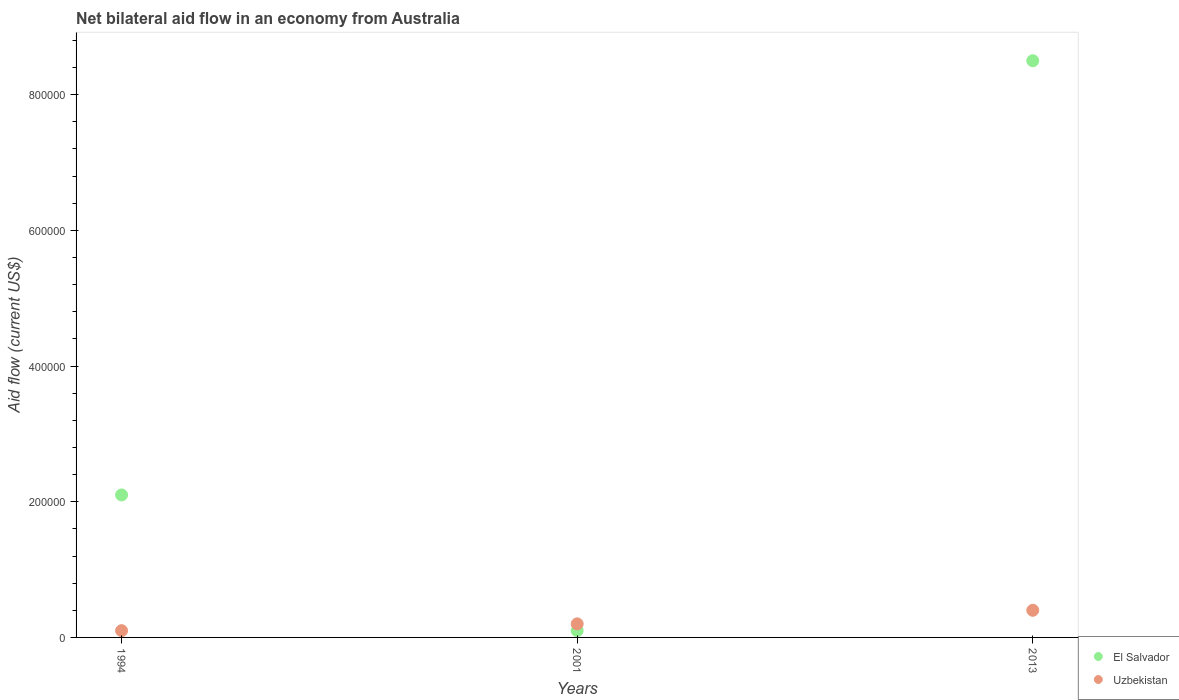How many different coloured dotlines are there?
Make the answer very short. 2. What is the net bilateral aid flow in El Salvador in 1994?
Ensure brevity in your answer.  2.10e+05. Across all years, what is the minimum net bilateral aid flow in Uzbekistan?
Provide a succinct answer. 10000. In which year was the net bilateral aid flow in El Salvador minimum?
Your answer should be very brief. 2001. What is the total net bilateral aid flow in Uzbekistan in the graph?
Ensure brevity in your answer.  7.00e+04. What is the difference between the net bilateral aid flow in Uzbekistan in 1994 and the net bilateral aid flow in El Salvador in 2013?
Provide a succinct answer. -8.40e+05. What is the average net bilateral aid flow in El Salvador per year?
Offer a very short reply. 3.57e+05. In the year 2013, what is the difference between the net bilateral aid flow in Uzbekistan and net bilateral aid flow in El Salvador?
Make the answer very short. -8.10e+05. In how many years, is the net bilateral aid flow in El Salvador greater than 280000 US$?
Your answer should be very brief. 1. What is the ratio of the net bilateral aid flow in El Salvador in 1994 to that in 2013?
Your response must be concise. 0.25. Is the difference between the net bilateral aid flow in Uzbekistan in 1994 and 2013 greater than the difference between the net bilateral aid flow in El Salvador in 1994 and 2013?
Offer a very short reply. Yes. What is the difference between the highest and the second highest net bilateral aid flow in El Salvador?
Offer a terse response. 6.40e+05. Does the net bilateral aid flow in Uzbekistan monotonically increase over the years?
Your answer should be compact. Yes. Is the net bilateral aid flow in Uzbekistan strictly less than the net bilateral aid flow in El Salvador over the years?
Give a very brief answer. No. How many dotlines are there?
Make the answer very short. 2. How many years are there in the graph?
Provide a succinct answer. 3. What is the difference between two consecutive major ticks on the Y-axis?
Your answer should be very brief. 2.00e+05. Does the graph contain any zero values?
Offer a terse response. No. How many legend labels are there?
Your answer should be compact. 2. How are the legend labels stacked?
Ensure brevity in your answer.  Vertical. What is the title of the graph?
Your answer should be very brief. Net bilateral aid flow in an economy from Australia. What is the label or title of the Y-axis?
Offer a very short reply. Aid flow (current US$). What is the Aid flow (current US$) in Uzbekistan in 1994?
Provide a short and direct response. 10000. What is the Aid flow (current US$) of El Salvador in 2001?
Give a very brief answer. 10000. What is the Aid flow (current US$) in El Salvador in 2013?
Provide a short and direct response. 8.50e+05. Across all years, what is the maximum Aid flow (current US$) in El Salvador?
Keep it short and to the point. 8.50e+05. What is the total Aid flow (current US$) of El Salvador in the graph?
Give a very brief answer. 1.07e+06. What is the total Aid flow (current US$) in Uzbekistan in the graph?
Offer a very short reply. 7.00e+04. What is the difference between the Aid flow (current US$) in El Salvador in 1994 and that in 2001?
Offer a terse response. 2.00e+05. What is the difference between the Aid flow (current US$) of El Salvador in 1994 and that in 2013?
Provide a succinct answer. -6.40e+05. What is the difference between the Aid flow (current US$) of El Salvador in 2001 and that in 2013?
Keep it short and to the point. -8.40e+05. What is the difference between the Aid flow (current US$) in Uzbekistan in 2001 and that in 2013?
Provide a short and direct response. -2.00e+04. What is the difference between the Aid flow (current US$) of El Salvador in 1994 and the Aid flow (current US$) of Uzbekistan in 2013?
Ensure brevity in your answer.  1.70e+05. What is the difference between the Aid flow (current US$) in El Salvador in 2001 and the Aid flow (current US$) in Uzbekistan in 2013?
Keep it short and to the point. -3.00e+04. What is the average Aid flow (current US$) of El Salvador per year?
Your answer should be very brief. 3.57e+05. What is the average Aid flow (current US$) in Uzbekistan per year?
Your answer should be very brief. 2.33e+04. In the year 2013, what is the difference between the Aid flow (current US$) of El Salvador and Aid flow (current US$) of Uzbekistan?
Make the answer very short. 8.10e+05. What is the ratio of the Aid flow (current US$) in El Salvador in 1994 to that in 2001?
Make the answer very short. 21. What is the ratio of the Aid flow (current US$) of Uzbekistan in 1994 to that in 2001?
Give a very brief answer. 0.5. What is the ratio of the Aid flow (current US$) in El Salvador in 1994 to that in 2013?
Your answer should be compact. 0.25. What is the ratio of the Aid flow (current US$) of Uzbekistan in 1994 to that in 2013?
Offer a very short reply. 0.25. What is the ratio of the Aid flow (current US$) of El Salvador in 2001 to that in 2013?
Keep it short and to the point. 0.01. What is the difference between the highest and the second highest Aid flow (current US$) in El Salvador?
Provide a succinct answer. 6.40e+05. What is the difference between the highest and the lowest Aid flow (current US$) of El Salvador?
Your response must be concise. 8.40e+05. 